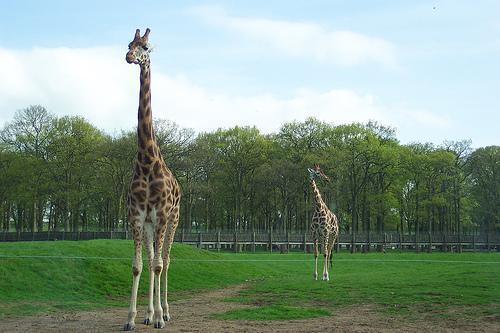How many legs do the giraffes have?
Give a very brief answer. 4. How many giraffes are pictured?
Give a very brief answer. 2. How many giraffes are there?
Give a very brief answer. 2. 